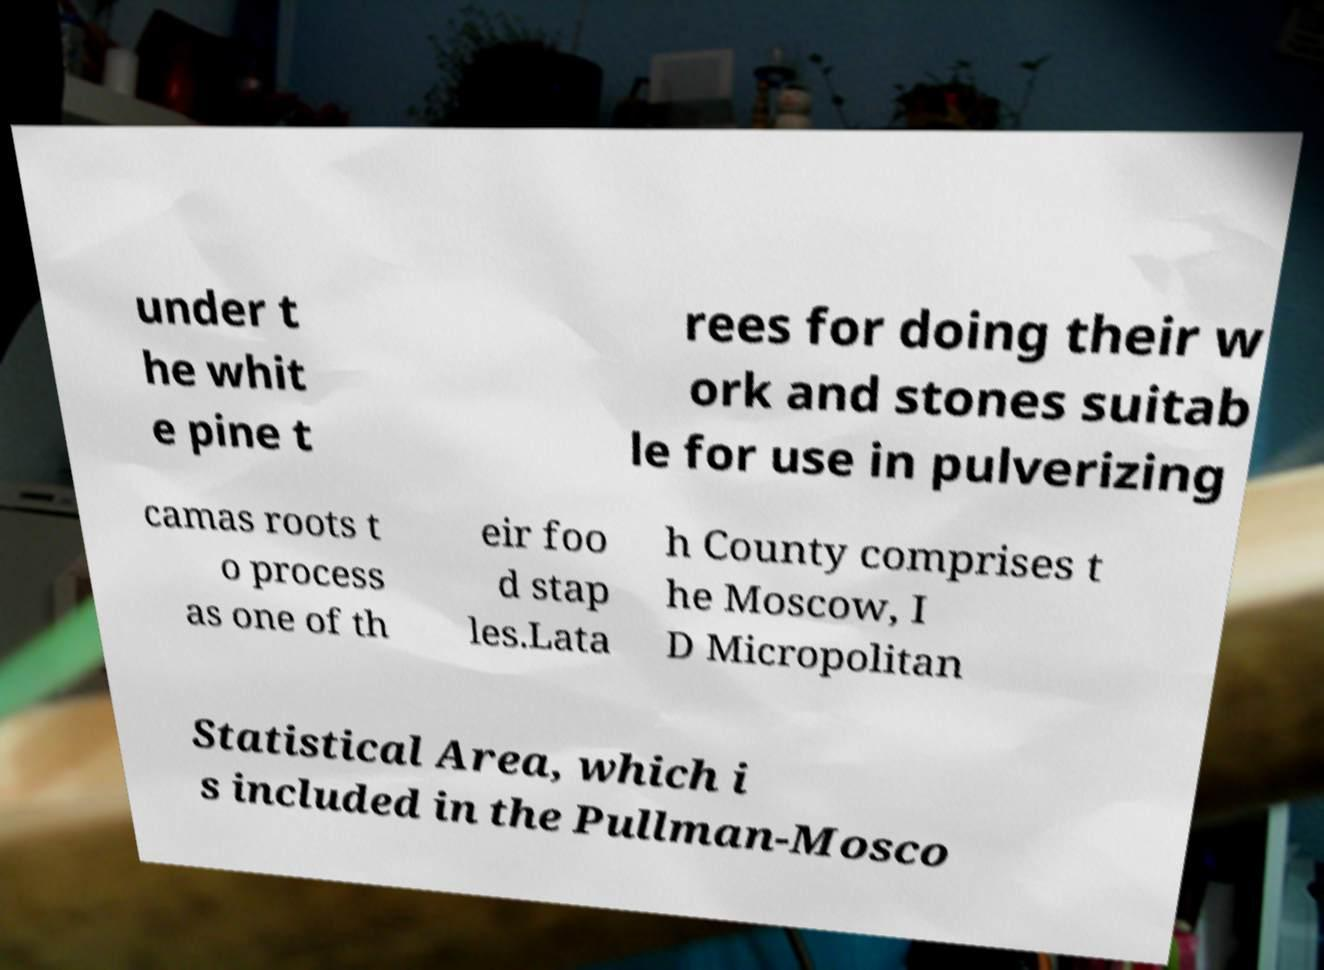What messages or text are displayed in this image? I need them in a readable, typed format. under t he whit e pine t rees for doing their w ork and stones suitab le for use in pulverizing camas roots t o process as one of th eir foo d stap les.Lata h County comprises t he Moscow, I D Micropolitan Statistical Area, which i s included in the Pullman-Mosco 